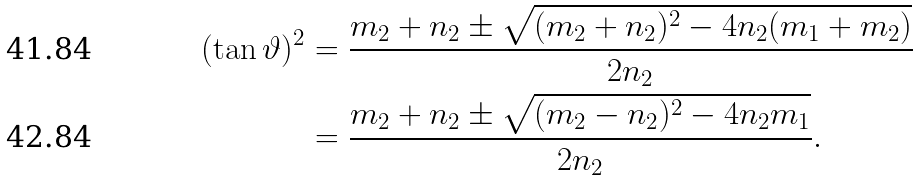Convert formula to latex. <formula><loc_0><loc_0><loc_500><loc_500>( \tan \vartheta ) ^ { 2 } & = \frac { m _ { 2 } + n _ { 2 } \pm \sqrt { ( m _ { 2 } + n _ { 2 } ) ^ { 2 } - 4 n _ { 2 } ( m _ { 1 } + m _ { 2 } ) } } { 2 n _ { 2 } } \\ & = \frac { m _ { 2 } + n _ { 2 } \pm \sqrt { ( m _ { 2 } - n _ { 2 } ) ^ { 2 } - 4 n _ { 2 } m _ { 1 } } } { 2 n _ { 2 } } .</formula> 